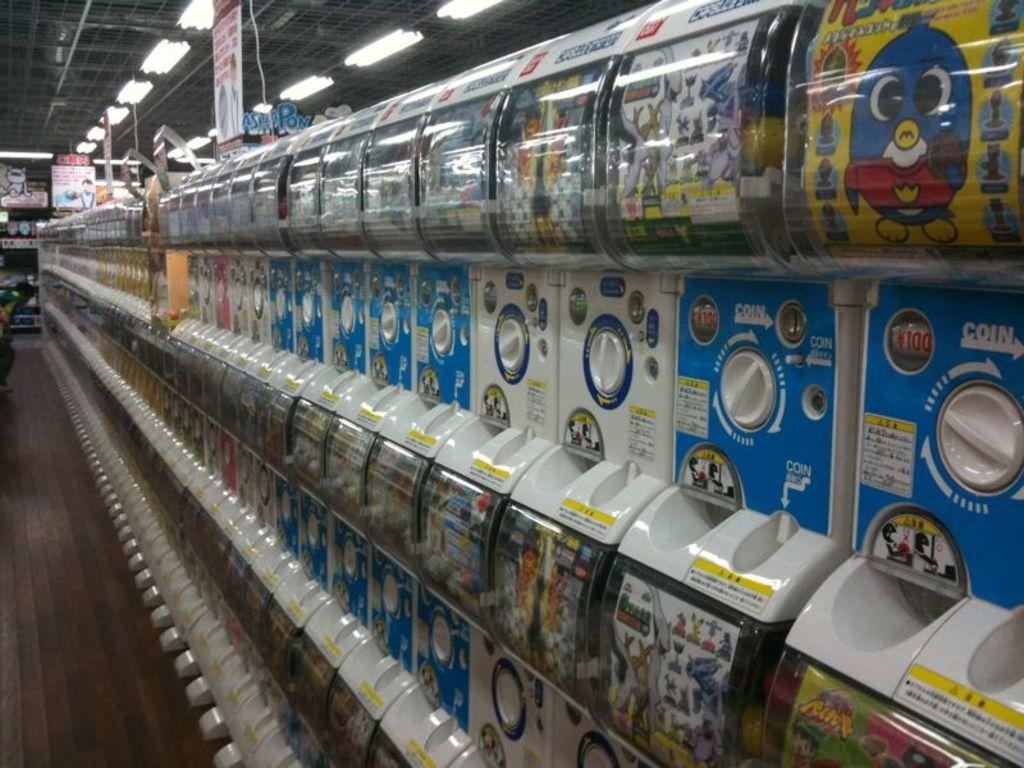Provide a one-sentence caption for the provided image. A row of vending machines that say coin in white. 